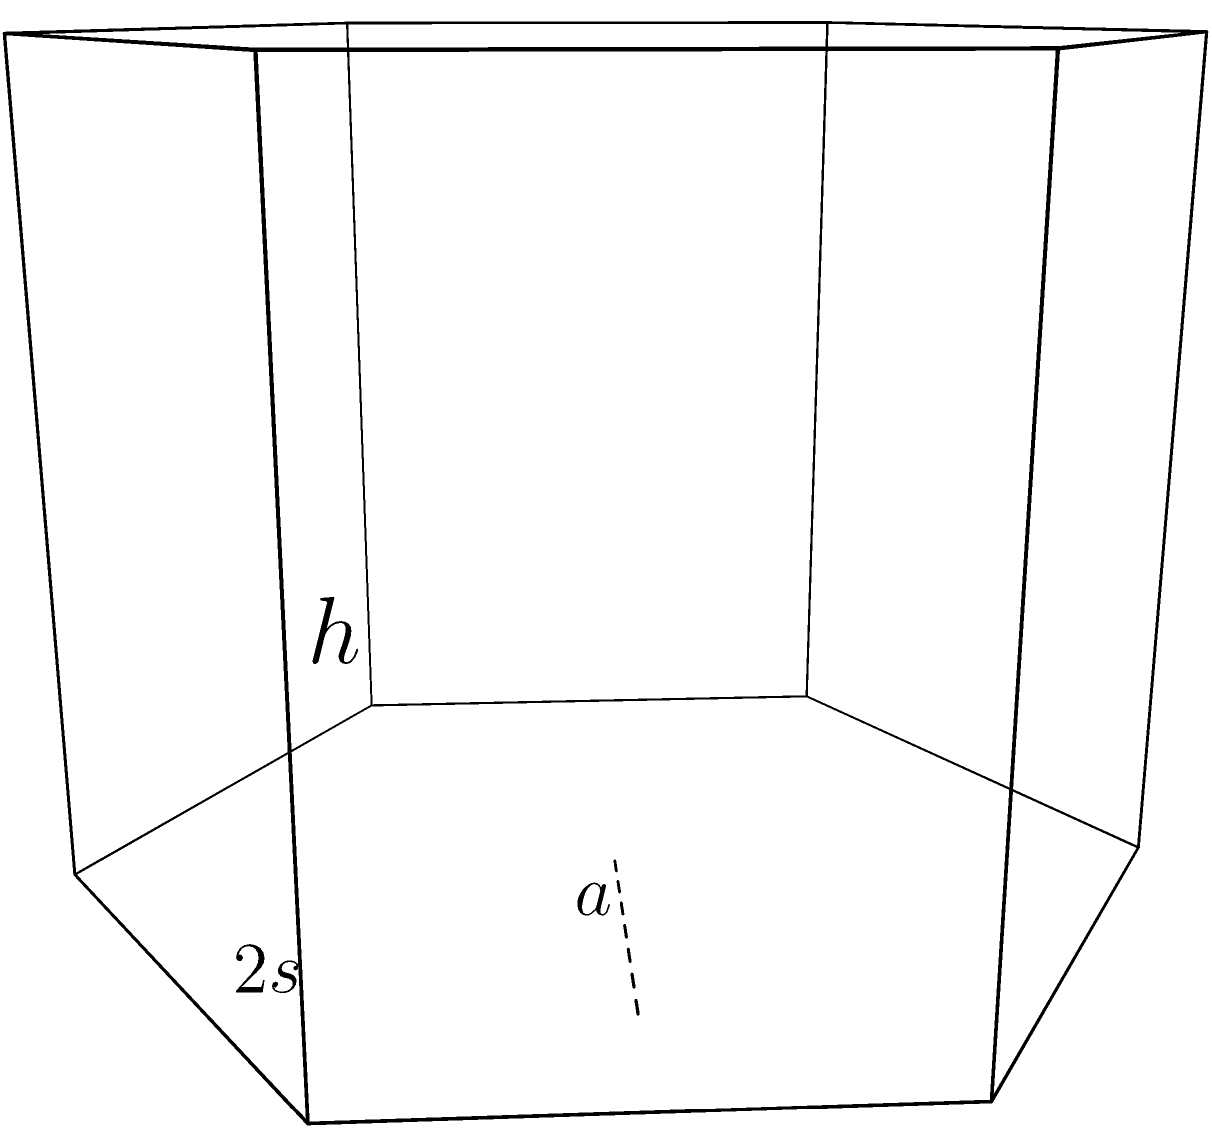As part of your sustainable manufacturing practices, you're designing hexagonal recycling bins for textile scraps. The bins have a side length of $s$ meters and a height of $h$ meters. If the total surface area of the bin (including the top and bottom) is 24 square meters and its volume is 9 cubic meters, calculate the side length $s$ and height $h$ of the bin. Let's approach this step-by-step:

1) For a regular hexagon, the area is given by $A = \frac{3\sqrt{3}}{2}s^2$, where $s$ is the side length.

2) The surface area of the hexagonal prism includes:
   - Top and bottom: $2 \cdot \frac{3\sqrt{3}}{2}s^2$
   - Six rectangular sides: $6 \cdot sh$

3) The total surface area equation:
   $24 = 3\sqrt{3}s^2 + 6sh$

4) The volume of a hexagonal prism is given by $V = \frac{3\sqrt{3}}{2}s^2h$

5) The volume equation:
   $9 = \frac{3\sqrt{3}}{2}s^2h$

6) From the volume equation, we can express $h$ in terms of $s$:
   $h = \frac{6}{\sqrt{3}s^2}$

7) Substituting this into the surface area equation:
   $24 = 3\sqrt{3}s^2 + 6s(\frac{6}{\sqrt{3}s^2})$
   $24 = 3\sqrt{3}s^2 + \frac{36}{\sqrt{3}}$

8) Simplifying:
   $24\sqrt{3} = 9s^2 + 36$
   $9s^2 = 24\sqrt{3} - 36$
   $s^2 = \frac{24\sqrt{3} - 36}{9}$

9) Solving for $s$:
   $s = \sqrt{\frac{24\sqrt{3} - 36}{9}} \approx 1.5$ meters

10) Using this value of $s$ in the equation for $h$:
    $h = \frac{6}{\sqrt{3}s^2} \approx 2$ meters

Therefore, the side length $s$ is approximately 1.5 meters, and the height $h$ is approximately 2 meters.
Answer: $s \approx 1.5$ m, $h \approx 2$ m 